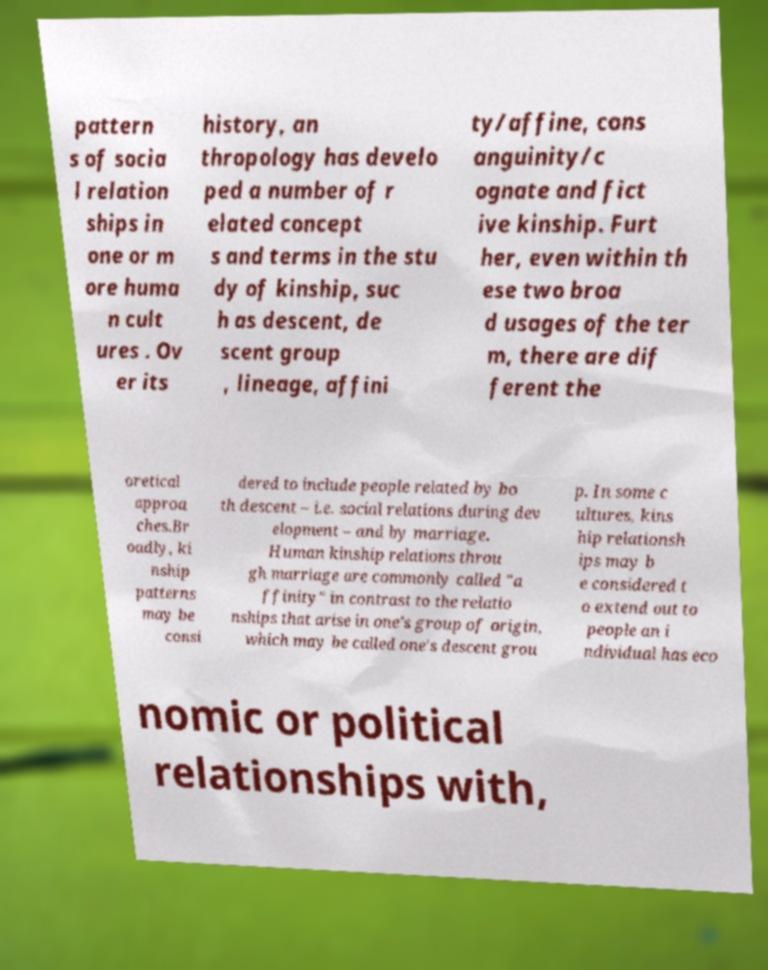Can you accurately transcribe the text from the provided image for me? pattern s of socia l relation ships in one or m ore huma n cult ures . Ov er its history, an thropology has develo ped a number of r elated concept s and terms in the stu dy of kinship, suc h as descent, de scent group , lineage, affini ty/affine, cons anguinity/c ognate and fict ive kinship. Furt her, even within th ese two broa d usages of the ter m, there are dif ferent the oretical approa ches.Br oadly, ki nship patterns may be consi dered to include people related by bo th descent – i.e. social relations during dev elopment – and by marriage. Human kinship relations throu gh marriage are commonly called "a ffinity" in contrast to the relatio nships that arise in one's group of origin, which may be called one's descent grou p. In some c ultures, kins hip relationsh ips may b e considered t o extend out to people an i ndividual has eco nomic or political relationships with, 